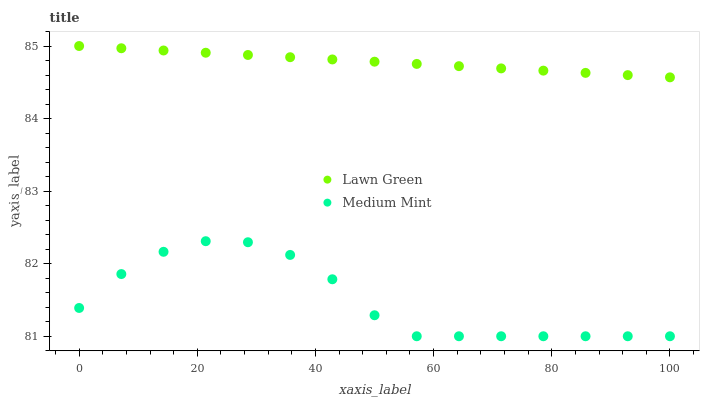Does Medium Mint have the minimum area under the curve?
Answer yes or no. Yes. Does Lawn Green have the maximum area under the curve?
Answer yes or no. Yes. Does Lawn Green have the minimum area under the curve?
Answer yes or no. No. Is Lawn Green the smoothest?
Answer yes or no. Yes. Is Medium Mint the roughest?
Answer yes or no. Yes. Is Lawn Green the roughest?
Answer yes or no. No. Does Medium Mint have the lowest value?
Answer yes or no. Yes. Does Lawn Green have the lowest value?
Answer yes or no. No. Does Lawn Green have the highest value?
Answer yes or no. Yes. Is Medium Mint less than Lawn Green?
Answer yes or no. Yes. Is Lawn Green greater than Medium Mint?
Answer yes or no. Yes. Does Medium Mint intersect Lawn Green?
Answer yes or no. No. 